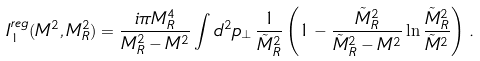<formula> <loc_0><loc_0><loc_500><loc_500>I _ { 1 } ^ { r e g } ( M ^ { 2 } , M _ { R } ^ { 2 } ) = \frac { i \pi M _ { R } ^ { 4 } } { M _ { R } ^ { 2 } - M ^ { 2 } } \int d ^ { 2 } p _ { \perp } \, \frac { 1 } { \tilde { M } _ { R } ^ { 2 } } \left ( 1 - \frac { \tilde { M } _ { R } ^ { 2 } } { \tilde { M } _ { R } ^ { 2 } - M ^ { 2 } } \ln \frac { \tilde { M } _ { R } ^ { 2 } } { \tilde { M } ^ { 2 } } \right ) \, .</formula> 